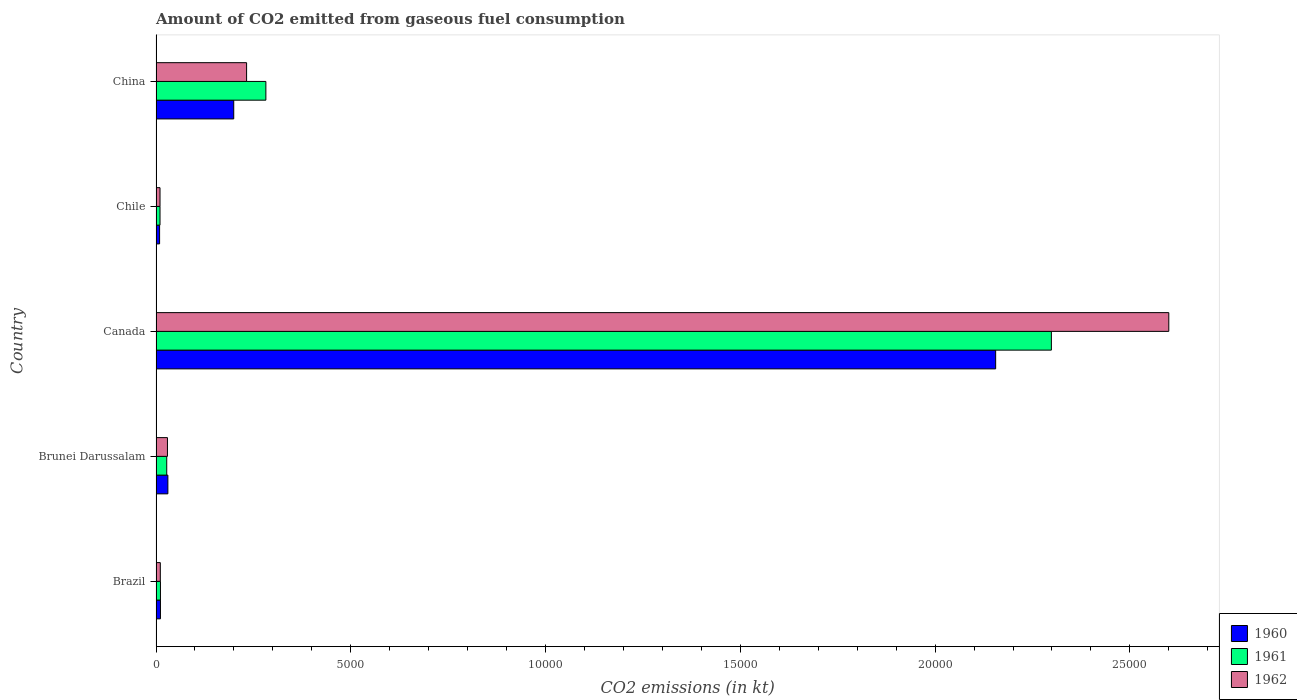How many different coloured bars are there?
Your answer should be compact. 3. Are the number of bars per tick equal to the number of legend labels?
Offer a very short reply. Yes. Are the number of bars on each tick of the Y-axis equal?
Provide a short and direct response. Yes. How many bars are there on the 3rd tick from the bottom?
Provide a short and direct response. 3. In how many cases, is the number of bars for a given country not equal to the number of legend labels?
Keep it short and to the point. 0. What is the amount of CO2 emitted in 1961 in Canada?
Make the answer very short. 2.30e+04. Across all countries, what is the maximum amount of CO2 emitted in 1960?
Offer a very short reply. 2.16e+04. Across all countries, what is the minimum amount of CO2 emitted in 1961?
Your answer should be very brief. 102.68. In which country was the amount of CO2 emitted in 1961 maximum?
Give a very brief answer. Canada. In which country was the amount of CO2 emitted in 1961 minimum?
Your response must be concise. Chile. What is the total amount of CO2 emitted in 1962 in the graph?
Offer a very short reply. 2.88e+04. What is the difference between the amount of CO2 emitted in 1960 in Brazil and that in Brunei Darussalam?
Provide a succinct answer. -190.68. What is the difference between the amount of CO2 emitted in 1961 in Brunei Darussalam and the amount of CO2 emitted in 1962 in Brazil?
Offer a very short reply. 165.01. What is the average amount of CO2 emitted in 1961 per country?
Your answer should be very brief. 5259.21. What is the difference between the amount of CO2 emitted in 1961 and amount of CO2 emitted in 1960 in China?
Offer a terse response. 825.07. What is the ratio of the amount of CO2 emitted in 1960 in Brazil to that in Canada?
Keep it short and to the point. 0.01. Is the amount of CO2 emitted in 1961 in Brazil less than that in Canada?
Keep it short and to the point. Yes. What is the difference between the highest and the second highest amount of CO2 emitted in 1960?
Offer a very short reply. 1.96e+04. What is the difference between the highest and the lowest amount of CO2 emitted in 1960?
Provide a short and direct response. 2.15e+04. In how many countries, is the amount of CO2 emitted in 1960 greater than the average amount of CO2 emitted in 1960 taken over all countries?
Keep it short and to the point. 1. Is the sum of the amount of CO2 emitted in 1960 in Canada and Chile greater than the maximum amount of CO2 emitted in 1961 across all countries?
Ensure brevity in your answer.  No. What does the 2nd bar from the top in Brazil represents?
Offer a terse response. 1961. How many countries are there in the graph?
Provide a succinct answer. 5. What is the difference between two consecutive major ticks on the X-axis?
Your answer should be compact. 5000. Are the values on the major ticks of X-axis written in scientific E-notation?
Offer a very short reply. No. Does the graph contain any zero values?
Your answer should be very brief. No. Does the graph contain grids?
Provide a short and direct response. No. Where does the legend appear in the graph?
Your response must be concise. Bottom right. How many legend labels are there?
Give a very brief answer. 3. What is the title of the graph?
Your answer should be compact. Amount of CO2 emitted from gaseous fuel consumption. What is the label or title of the X-axis?
Keep it short and to the point. CO2 emissions (in kt). What is the CO2 emissions (in kt) of 1960 in Brazil?
Give a very brief answer. 113.68. What is the CO2 emissions (in kt) in 1961 in Brazil?
Your response must be concise. 113.68. What is the CO2 emissions (in kt) of 1962 in Brazil?
Offer a very short reply. 110.01. What is the CO2 emissions (in kt) of 1960 in Brunei Darussalam?
Give a very brief answer. 304.36. What is the CO2 emissions (in kt) in 1961 in Brunei Darussalam?
Provide a succinct answer. 275.02. What is the CO2 emissions (in kt) of 1962 in Brunei Darussalam?
Offer a very short reply. 293.36. What is the CO2 emissions (in kt) of 1960 in Canada?
Your answer should be very brief. 2.16e+04. What is the CO2 emissions (in kt) of 1961 in Canada?
Provide a short and direct response. 2.30e+04. What is the CO2 emissions (in kt) of 1962 in Canada?
Ensure brevity in your answer.  2.60e+04. What is the CO2 emissions (in kt) of 1960 in Chile?
Provide a short and direct response. 91.67. What is the CO2 emissions (in kt) in 1961 in Chile?
Ensure brevity in your answer.  102.68. What is the CO2 emissions (in kt) of 1962 in Chile?
Make the answer very short. 102.68. What is the CO2 emissions (in kt) in 1960 in China?
Ensure brevity in your answer.  1994.85. What is the CO2 emissions (in kt) in 1961 in China?
Provide a short and direct response. 2819.92. What is the CO2 emissions (in kt) in 1962 in China?
Provide a succinct answer. 2324.88. Across all countries, what is the maximum CO2 emissions (in kt) of 1960?
Offer a very short reply. 2.16e+04. Across all countries, what is the maximum CO2 emissions (in kt) in 1961?
Your answer should be compact. 2.30e+04. Across all countries, what is the maximum CO2 emissions (in kt) of 1962?
Provide a short and direct response. 2.60e+04. Across all countries, what is the minimum CO2 emissions (in kt) of 1960?
Keep it short and to the point. 91.67. Across all countries, what is the minimum CO2 emissions (in kt) in 1961?
Offer a terse response. 102.68. Across all countries, what is the minimum CO2 emissions (in kt) of 1962?
Your answer should be very brief. 102.68. What is the total CO2 emissions (in kt) in 1960 in the graph?
Your answer should be compact. 2.41e+04. What is the total CO2 emissions (in kt) in 1961 in the graph?
Provide a short and direct response. 2.63e+04. What is the total CO2 emissions (in kt) in 1962 in the graph?
Your answer should be very brief. 2.88e+04. What is the difference between the CO2 emissions (in kt) in 1960 in Brazil and that in Brunei Darussalam?
Give a very brief answer. -190.68. What is the difference between the CO2 emissions (in kt) of 1961 in Brazil and that in Brunei Darussalam?
Offer a very short reply. -161.35. What is the difference between the CO2 emissions (in kt) of 1962 in Brazil and that in Brunei Darussalam?
Your answer should be very brief. -183.35. What is the difference between the CO2 emissions (in kt) in 1960 in Brazil and that in Canada?
Your answer should be compact. -2.14e+04. What is the difference between the CO2 emissions (in kt) in 1961 in Brazil and that in Canada?
Your answer should be very brief. -2.29e+04. What is the difference between the CO2 emissions (in kt) of 1962 in Brazil and that in Canada?
Provide a succinct answer. -2.59e+04. What is the difference between the CO2 emissions (in kt) of 1960 in Brazil and that in Chile?
Keep it short and to the point. 22. What is the difference between the CO2 emissions (in kt) of 1961 in Brazil and that in Chile?
Keep it short and to the point. 11. What is the difference between the CO2 emissions (in kt) in 1962 in Brazil and that in Chile?
Provide a short and direct response. 7.33. What is the difference between the CO2 emissions (in kt) of 1960 in Brazil and that in China?
Your answer should be compact. -1881.17. What is the difference between the CO2 emissions (in kt) of 1961 in Brazil and that in China?
Make the answer very short. -2706.25. What is the difference between the CO2 emissions (in kt) in 1962 in Brazil and that in China?
Provide a short and direct response. -2214.87. What is the difference between the CO2 emissions (in kt) of 1960 in Brunei Darussalam and that in Canada?
Your response must be concise. -2.13e+04. What is the difference between the CO2 emissions (in kt) in 1961 in Brunei Darussalam and that in Canada?
Give a very brief answer. -2.27e+04. What is the difference between the CO2 emissions (in kt) of 1962 in Brunei Darussalam and that in Canada?
Your answer should be very brief. -2.57e+04. What is the difference between the CO2 emissions (in kt) in 1960 in Brunei Darussalam and that in Chile?
Keep it short and to the point. 212.69. What is the difference between the CO2 emissions (in kt) in 1961 in Brunei Darussalam and that in Chile?
Keep it short and to the point. 172.35. What is the difference between the CO2 emissions (in kt) in 1962 in Brunei Darussalam and that in Chile?
Offer a very short reply. 190.68. What is the difference between the CO2 emissions (in kt) of 1960 in Brunei Darussalam and that in China?
Ensure brevity in your answer.  -1690.49. What is the difference between the CO2 emissions (in kt) of 1961 in Brunei Darussalam and that in China?
Offer a very short reply. -2544.9. What is the difference between the CO2 emissions (in kt) in 1962 in Brunei Darussalam and that in China?
Offer a terse response. -2031.52. What is the difference between the CO2 emissions (in kt) in 1960 in Canada and that in Chile?
Offer a terse response. 2.15e+04. What is the difference between the CO2 emissions (in kt) in 1961 in Canada and that in Chile?
Your answer should be very brief. 2.29e+04. What is the difference between the CO2 emissions (in kt) of 1962 in Canada and that in Chile?
Ensure brevity in your answer.  2.59e+04. What is the difference between the CO2 emissions (in kt) in 1960 in Canada and that in China?
Your answer should be compact. 1.96e+04. What is the difference between the CO2 emissions (in kt) of 1961 in Canada and that in China?
Give a very brief answer. 2.02e+04. What is the difference between the CO2 emissions (in kt) of 1962 in Canada and that in China?
Your answer should be very brief. 2.37e+04. What is the difference between the CO2 emissions (in kt) in 1960 in Chile and that in China?
Your response must be concise. -1903.17. What is the difference between the CO2 emissions (in kt) in 1961 in Chile and that in China?
Your answer should be compact. -2717.25. What is the difference between the CO2 emissions (in kt) of 1962 in Chile and that in China?
Provide a short and direct response. -2222.2. What is the difference between the CO2 emissions (in kt) in 1960 in Brazil and the CO2 emissions (in kt) in 1961 in Brunei Darussalam?
Offer a very short reply. -161.35. What is the difference between the CO2 emissions (in kt) of 1960 in Brazil and the CO2 emissions (in kt) of 1962 in Brunei Darussalam?
Your response must be concise. -179.68. What is the difference between the CO2 emissions (in kt) in 1961 in Brazil and the CO2 emissions (in kt) in 1962 in Brunei Darussalam?
Offer a terse response. -179.68. What is the difference between the CO2 emissions (in kt) in 1960 in Brazil and the CO2 emissions (in kt) in 1961 in Canada?
Offer a very short reply. -2.29e+04. What is the difference between the CO2 emissions (in kt) in 1960 in Brazil and the CO2 emissions (in kt) in 1962 in Canada?
Your answer should be compact. -2.59e+04. What is the difference between the CO2 emissions (in kt) in 1961 in Brazil and the CO2 emissions (in kt) in 1962 in Canada?
Provide a short and direct response. -2.59e+04. What is the difference between the CO2 emissions (in kt) of 1960 in Brazil and the CO2 emissions (in kt) of 1961 in Chile?
Make the answer very short. 11. What is the difference between the CO2 emissions (in kt) of 1960 in Brazil and the CO2 emissions (in kt) of 1962 in Chile?
Provide a short and direct response. 11. What is the difference between the CO2 emissions (in kt) in 1961 in Brazil and the CO2 emissions (in kt) in 1962 in Chile?
Provide a short and direct response. 11. What is the difference between the CO2 emissions (in kt) in 1960 in Brazil and the CO2 emissions (in kt) in 1961 in China?
Your response must be concise. -2706.25. What is the difference between the CO2 emissions (in kt) in 1960 in Brazil and the CO2 emissions (in kt) in 1962 in China?
Offer a very short reply. -2211.2. What is the difference between the CO2 emissions (in kt) of 1961 in Brazil and the CO2 emissions (in kt) of 1962 in China?
Provide a short and direct response. -2211.2. What is the difference between the CO2 emissions (in kt) in 1960 in Brunei Darussalam and the CO2 emissions (in kt) in 1961 in Canada?
Provide a short and direct response. -2.27e+04. What is the difference between the CO2 emissions (in kt) of 1960 in Brunei Darussalam and the CO2 emissions (in kt) of 1962 in Canada?
Provide a short and direct response. -2.57e+04. What is the difference between the CO2 emissions (in kt) in 1961 in Brunei Darussalam and the CO2 emissions (in kt) in 1962 in Canada?
Offer a terse response. -2.57e+04. What is the difference between the CO2 emissions (in kt) of 1960 in Brunei Darussalam and the CO2 emissions (in kt) of 1961 in Chile?
Offer a very short reply. 201.69. What is the difference between the CO2 emissions (in kt) of 1960 in Brunei Darussalam and the CO2 emissions (in kt) of 1962 in Chile?
Give a very brief answer. 201.69. What is the difference between the CO2 emissions (in kt) of 1961 in Brunei Darussalam and the CO2 emissions (in kt) of 1962 in Chile?
Keep it short and to the point. 172.35. What is the difference between the CO2 emissions (in kt) of 1960 in Brunei Darussalam and the CO2 emissions (in kt) of 1961 in China?
Keep it short and to the point. -2515.56. What is the difference between the CO2 emissions (in kt) of 1960 in Brunei Darussalam and the CO2 emissions (in kt) of 1962 in China?
Provide a short and direct response. -2020.52. What is the difference between the CO2 emissions (in kt) of 1961 in Brunei Darussalam and the CO2 emissions (in kt) of 1962 in China?
Your answer should be very brief. -2049.85. What is the difference between the CO2 emissions (in kt) of 1960 in Canada and the CO2 emissions (in kt) of 1961 in Chile?
Your answer should be compact. 2.15e+04. What is the difference between the CO2 emissions (in kt) in 1960 in Canada and the CO2 emissions (in kt) in 1962 in Chile?
Offer a terse response. 2.15e+04. What is the difference between the CO2 emissions (in kt) in 1961 in Canada and the CO2 emissions (in kt) in 1962 in Chile?
Keep it short and to the point. 2.29e+04. What is the difference between the CO2 emissions (in kt) of 1960 in Canada and the CO2 emissions (in kt) of 1961 in China?
Offer a terse response. 1.87e+04. What is the difference between the CO2 emissions (in kt) of 1960 in Canada and the CO2 emissions (in kt) of 1962 in China?
Your answer should be very brief. 1.92e+04. What is the difference between the CO2 emissions (in kt) in 1961 in Canada and the CO2 emissions (in kt) in 1962 in China?
Give a very brief answer. 2.07e+04. What is the difference between the CO2 emissions (in kt) of 1960 in Chile and the CO2 emissions (in kt) of 1961 in China?
Make the answer very short. -2728.25. What is the difference between the CO2 emissions (in kt) of 1960 in Chile and the CO2 emissions (in kt) of 1962 in China?
Give a very brief answer. -2233.2. What is the difference between the CO2 emissions (in kt) of 1961 in Chile and the CO2 emissions (in kt) of 1962 in China?
Provide a short and direct response. -2222.2. What is the average CO2 emissions (in kt) of 1960 per country?
Your answer should be very brief. 4811.84. What is the average CO2 emissions (in kt) in 1961 per country?
Keep it short and to the point. 5259.21. What is the average CO2 emissions (in kt) of 1962 per country?
Ensure brevity in your answer.  5765.99. What is the difference between the CO2 emissions (in kt) in 1960 and CO2 emissions (in kt) in 1962 in Brazil?
Your response must be concise. 3.67. What is the difference between the CO2 emissions (in kt) of 1961 and CO2 emissions (in kt) of 1962 in Brazil?
Offer a terse response. 3.67. What is the difference between the CO2 emissions (in kt) in 1960 and CO2 emissions (in kt) in 1961 in Brunei Darussalam?
Ensure brevity in your answer.  29.34. What is the difference between the CO2 emissions (in kt) in 1960 and CO2 emissions (in kt) in 1962 in Brunei Darussalam?
Keep it short and to the point. 11. What is the difference between the CO2 emissions (in kt) in 1961 and CO2 emissions (in kt) in 1962 in Brunei Darussalam?
Offer a terse response. -18.34. What is the difference between the CO2 emissions (in kt) in 1960 and CO2 emissions (in kt) in 1961 in Canada?
Your answer should be compact. -1430.13. What is the difference between the CO2 emissions (in kt) in 1960 and CO2 emissions (in kt) in 1962 in Canada?
Your answer should be compact. -4444.4. What is the difference between the CO2 emissions (in kt) in 1961 and CO2 emissions (in kt) in 1962 in Canada?
Your answer should be compact. -3014.27. What is the difference between the CO2 emissions (in kt) in 1960 and CO2 emissions (in kt) in 1961 in Chile?
Provide a succinct answer. -11. What is the difference between the CO2 emissions (in kt) of 1960 and CO2 emissions (in kt) of 1962 in Chile?
Keep it short and to the point. -11. What is the difference between the CO2 emissions (in kt) in 1960 and CO2 emissions (in kt) in 1961 in China?
Offer a terse response. -825.08. What is the difference between the CO2 emissions (in kt) in 1960 and CO2 emissions (in kt) in 1962 in China?
Offer a terse response. -330.03. What is the difference between the CO2 emissions (in kt) of 1961 and CO2 emissions (in kt) of 1962 in China?
Ensure brevity in your answer.  495.05. What is the ratio of the CO2 emissions (in kt) of 1960 in Brazil to that in Brunei Darussalam?
Keep it short and to the point. 0.37. What is the ratio of the CO2 emissions (in kt) of 1961 in Brazil to that in Brunei Darussalam?
Give a very brief answer. 0.41. What is the ratio of the CO2 emissions (in kt) in 1962 in Brazil to that in Brunei Darussalam?
Offer a terse response. 0.38. What is the ratio of the CO2 emissions (in kt) of 1960 in Brazil to that in Canada?
Your answer should be compact. 0.01. What is the ratio of the CO2 emissions (in kt) of 1961 in Brazil to that in Canada?
Give a very brief answer. 0. What is the ratio of the CO2 emissions (in kt) of 1962 in Brazil to that in Canada?
Keep it short and to the point. 0. What is the ratio of the CO2 emissions (in kt) in 1960 in Brazil to that in Chile?
Give a very brief answer. 1.24. What is the ratio of the CO2 emissions (in kt) of 1961 in Brazil to that in Chile?
Your answer should be compact. 1.11. What is the ratio of the CO2 emissions (in kt) in 1962 in Brazil to that in Chile?
Your answer should be compact. 1.07. What is the ratio of the CO2 emissions (in kt) of 1960 in Brazil to that in China?
Ensure brevity in your answer.  0.06. What is the ratio of the CO2 emissions (in kt) of 1961 in Brazil to that in China?
Keep it short and to the point. 0.04. What is the ratio of the CO2 emissions (in kt) of 1962 in Brazil to that in China?
Your answer should be very brief. 0.05. What is the ratio of the CO2 emissions (in kt) of 1960 in Brunei Darussalam to that in Canada?
Keep it short and to the point. 0.01. What is the ratio of the CO2 emissions (in kt) in 1961 in Brunei Darussalam to that in Canada?
Keep it short and to the point. 0.01. What is the ratio of the CO2 emissions (in kt) in 1962 in Brunei Darussalam to that in Canada?
Your answer should be compact. 0.01. What is the ratio of the CO2 emissions (in kt) of 1960 in Brunei Darussalam to that in Chile?
Give a very brief answer. 3.32. What is the ratio of the CO2 emissions (in kt) of 1961 in Brunei Darussalam to that in Chile?
Keep it short and to the point. 2.68. What is the ratio of the CO2 emissions (in kt) in 1962 in Brunei Darussalam to that in Chile?
Provide a short and direct response. 2.86. What is the ratio of the CO2 emissions (in kt) of 1960 in Brunei Darussalam to that in China?
Provide a short and direct response. 0.15. What is the ratio of the CO2 emissions (in kt) of 1961 in Brunei Darussalam to that in China?
Provide a short and direct response. 0.1. What is the ratio of the CO2 emissions (in kt) in 1962 in Brunei Darussalam to that in China?
Provide a succinct answer. 0.13. What is the ratio of the CO2 emissions (in kt) of 1960 in Canada to that in Chile?
Keep it short and to the point. 235.12. What is the ratio of the CO2 emissions (in kt) of 1961 in Canada to that in Chile?
Offer a terse response. 223.86. What is the ratio of the CO2 emissions (in kt) in 1962 in Canada to that in Chile?
Ensure brevity in your answer.  253.21. What is the ratio of the CO2 emissions (in kt) of 1960 in Canada to that in China?
Offer a terse response. 10.81. What is the ratio of the CO2 emissions (in kt) of 1961 in Canada to that in China?
Provide a short and direct response. 8.15. What is the ratio of the CO2 emissions (in kt) in 1962 in Canada to that in China?
Your answer should be compact. 11.18. What is the ratio of the CO2 emissions (in kt) in 1960 in Chile to that in China?
Offer a terse response. 0.05. What is the ratio of the CO2 emissions (in kt) of 1961 in Chile to that in China?
Make the answer very short. 0.04. What is the ratio of the CO2 emissions (in kt) of 1962 in Chile to that in China?
Your answer should be compact. 0.04. What is the difference between the highest and the second highest CO2 emissions (in kt) in 1960?
Your answer should be very brief. 1.96e+04. What is the difference between the highest and the second highest CO2 emissions (in kt) of 1961?
Give a very brief answer. 2.02e+04. What is the difference between the highest and the second highest CO2 emissions (in kt) in 1962?
Keep it short and to the point. 2.37e+04. What is the difference between the highest and the lowest CO2 emissions (in kt) of 1960?
Your response must be concise. 2.15e+04. What is the difference between the highest and the lowest CO2 emissions (in kt) of 1961?
Provide a short and direct response. 2.29e+04. What is the difference between the highest and the lowest CO2 emissions (in kt) of 1962?
Provide a short and direct response. 2.59e+04. 